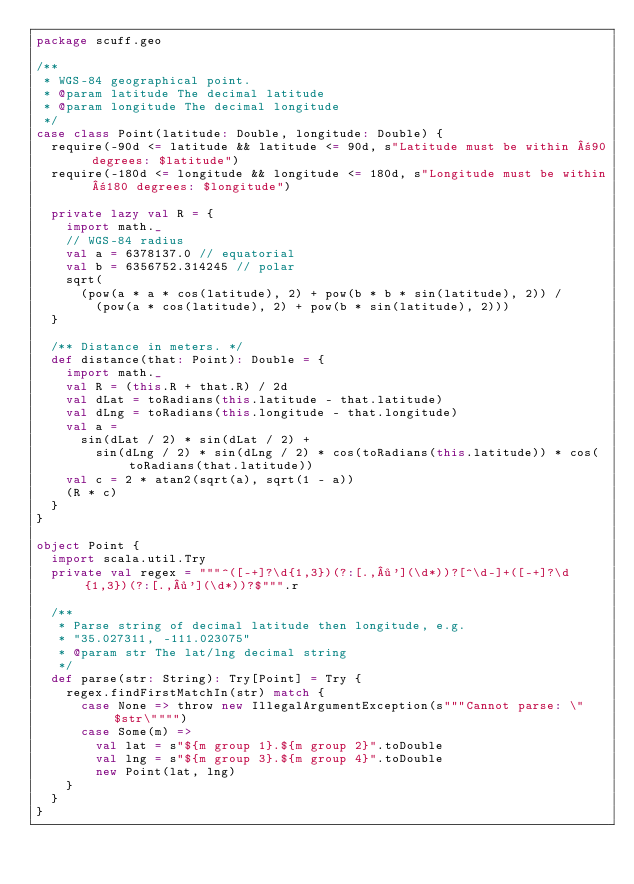Convert code to text. <code><loc_0><loc_0><loc_500><loc_500><_Scala_>package scuff.geo

/**
 * WGS-84 geographical point.
 * @param latitude The decimal latitude
 * @param longitude The decimal longitude
 */
case class Point(latitude: Double, longitude: Double) {
  require(-90d <= latitude && latitude <= 90d, s"Latitude must be within ±90 degrees: $latitude")
  require(-180d <= longitude && longitude <= 180d, s"Longitude must be within ±180 degrees: $longitude")

  private lazy val R = {
    import math._
    // WGS-84 radius
    val a = 6378137.0 // equatorial
    val b = 6356752.314245 // polar
    sqrt(
      (pow(a * a * cos(latitude), 2) + pow(b * b * sin(latitude), 2)) /
        (pow(a * cos(latitude), 2) + pow(b * sin(latitude), 2)))
  }

  /** Distance in meters. */
  def distance(that: Point): Double = {
    import math._
    val R = (this.R + that.R) / 2d
    val dLat = toRadians(this.latitude - that.latitude)
    val dLng = toRadians(this.longitude - that.longitude)
    val a =
      sin(dLat / 2) * sin(dLat / 2) +
        sin(dLng / 2) * sin(dLng / 2) * cos(toRadians(this.latitude)) * cos(toRadians(that.latitude))
    val c = 2 * atan2(sqrt(a), sqrt(1 - a))
    (R * c)
  }
}

object Point {
  import scala.util.Try
  private val regex = """^([-+]?\d{1,3})(?:[.,·'](\d*))?[^\d-]+([-+]?\d{1,3})(?:[.,·'](\d*))?$""".r

  /**
   * Parse string of decimal latitude then longitude, e.g.
   * "35.027311, -111.023075"
   * @param str The lat/lng decimal string
   */
  def parse(str: String): Try[Point] = Try {
    regex.findFirstMatchIn(str) match {
      case None => throw new IllegalArgumentException(s"""Cannot parse: \"$str\"""")
      case Some(m) =>
        val lat = s"${m group 1}.${m group 2}".toDouble
        val lng = s"${m group 3}.${m group 4}".toDouble
        new Point(lat, lng)
    }
  }
}
</code> 